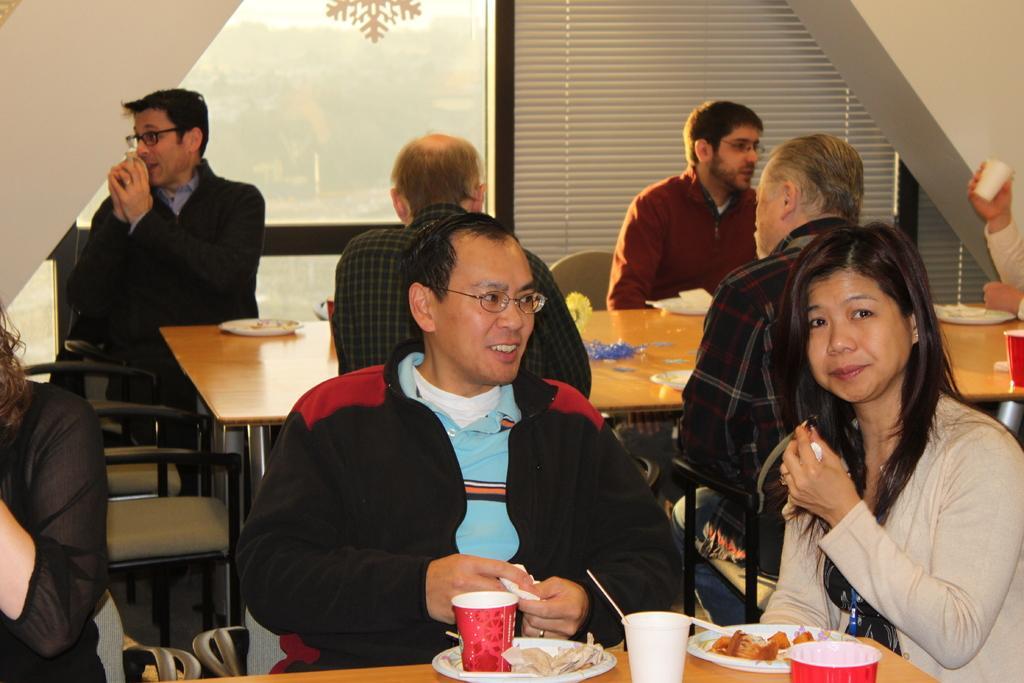How would you summarize this image in a sentence or two? In this picture we can see a group of people sitting on chairs some are smiling and some are sneezing and in front of them there is table and on table we can see plate, flowers,papers, glass with some food and in background we can see wall, trees, windows. 